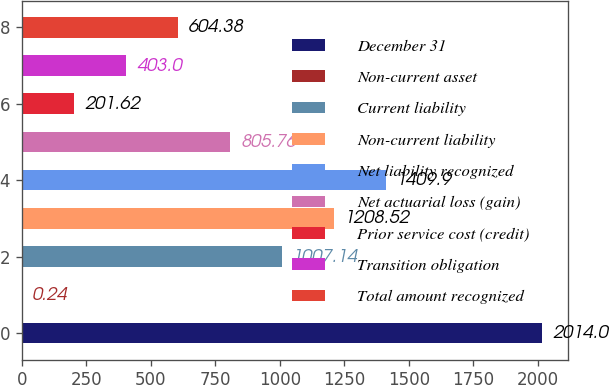<chart> <loc_0><loc_0><loc_500><loc_500><bar_chart><fcel>December 31<fcel>Non-current asset<fcel>Current liability<fcel>Non-current liability<fcel>Net liability recognized<fcel>Net actuarial loss (gain)<fcel>Prior service cost (credit)<fcel>Transition obligation<fcel>Total amount recognized<nl><fcel>2014<fcel>0.24<fcel>1007.14<fcel>1208.52<fcel>1409.9<fcel>805.76<fcel>201.62<fcel>403<fcel>604.38<nl></chart> 